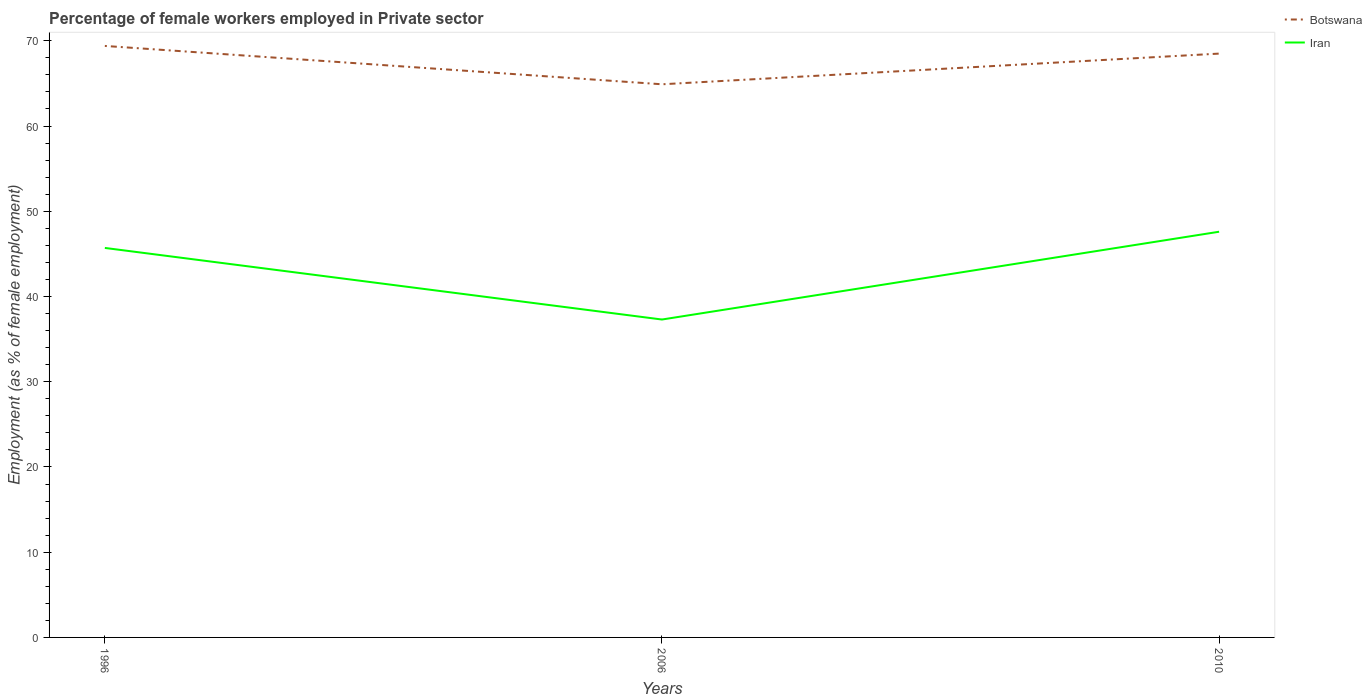Across all years, what is the maximum percentage of females employed in Private sector in Iran?
Your answer should be very brief. 37.3. What is the total percentage of females employed in Private sector in Iran in the graph?
Ensure brevity in your answer.  -10.3. What is the difference between the highest and the second highest percentage of females employed in Private sector in Iran?
Your answer should be compact. 10.3. What is the difference between the highest and the lowest percentage of females employed in Private sector in Iran?
Provide a short and direct response. 2. Is the percentage of females employed in Private sector in Iran strictly greater than the percentage of females employed in Private sector in Botswana over the years?
Your answer should be compact. Yes. How many years are there in the graph?
Your answer should be compact. 3. Are the values on the major ticks of Y-axis written in scientific E-notation?
Your response must be concise. No. Does the graph contain any zero values?
Your answer should be very brief. No. Does the graph contain grids?
Ensure brevity in your answer.  No. Where does the legend appear in the graph?
Your response must be concise. Top right. How many legend labels are there?
Offer a terse response. 2. What is the title of the graph?
Keep it short and to the point. Percentage of female workers employed in Private sector. What is the label or title of the X-axis?
Keep it short and to the point. Years. What is the label or title of the Y-axis?
Provide a succinct answer. Employment (as % of female employment). What is the Employment (as % of female employment) in Botswana in 1996?
Ensure brevity in your answer.  69.4. What is the Employment (as % of female employment) in Iran in 1996?
Offer a very short reply. 45.7. What is the Employment (as % of female employment) in Botswana in 2006?
Provide a short and direct response. 64.9. What is the Employment (as % of female employment) in Iran in 2006?
Provide a short and direct response. 37.3. What is the Employment (as % of female employment) of Botswana in 2010?
Offer a terse response. 68.5. What is the Employment (as % of female employment) of Iran in 2010?
Your response must be concise. 47.6. Across all years, what is the maximum Employment (as % of female employment) of Botswana?
Your answer should be compact. 69.4. Across all years, what is the maximum Employment (as % of female employment) in Iran?
Offer a very short reply. 47.6. Across all years, what is the minimum Employment (as % of female employment) of Botswana?
Provide a short and direct response. 64.9. Across all years, what is the minimum Employment (as % of female employment) in Iran?
Offer a very short reply. 37.3. What is the total Employment (as % of female employment) in Botswana in the graph?
Give a very brief answer. 202.8. What is the total Employment (as % of female employment) in Iran in the graph?
Keep it short and to the point. 130.6. What is the difference between the Employment (as % of female employment) in Botswana in 1996 and that in 2006?
Provide a succinct answer. 4.5. What is the difference between the Employment (as % of female employment) in Iran in 1996 and that in 2006?
Keep it short and to the point. 8.4. What is the difference between the Employment (as % of female employment) in Iran in 1996 and that in 2010?
Your answer should be very brief. -1.9. What is the difference between the Employment (as % of female employment) of Iran in 2006 and that in 2010?
Your answer should be very brief. -10.3. What is the difference between the Employment (as % of female employment) of Botswana in 1996 and the Employment (as % of female employment) of Iran in 2006?
Provide a succinct answer. 32.1. What is the difference between the Employment (as % of female employment) of Botswana in 1996 and the Employment (as % of female employment) of Iran in 2010?
Ensure brevity in your answer.  21.8. What is the average Employment (as % of female employment) of Botswana per year?
Your response must be concise. 67.6. What is the average Employment (as % of female employment) in Iran per year?
Your answer should be very brief. 43.53. In the year 1996, what is the difference between the Employment (as % of female employment) in Botswana and Employment (as % of female employment) in Iran?
Provide a succinct answer. 23.7. In the year 2006, what is the difference between the Employment (as % of female employment) in Botswana and Employment (as % of female employment) in Iran?
Offer a terse response. 27.6. In the year 2010, what is the difference between the Employment (as % of female employment) in Botswana and Employment (as % of female employment) in Iran?
Keep it short and to the point. 20.9. What is the ratio of the Employment (as % of female employment) in Botswana in 1996 to that in 2006?
Make the answer very short. 1.07. What is the ratio of the Employment (as % of female employment) in Iran in 1996 to that in 2006?
Offer a very short reply. 1.23. What is the ratio of the Employment (as % of female employment) of Botswana in 1996 to that in 2010?
Give a very brief answer. 1.01. What is the ratio of the Employment (as % of female employment) of Iran in 1996 to that in 2010?
Ensure brevity in your answer.  0.96. What is the ratio of the Employment (as % of female employment) in Iran in 2006 to that in 2010?
Make the answer very short. 0.78. What is the difference between the highest and the second highest Employment (as % of female employment) in Botswana?
Offer a very short reply. 0.9. What is the difference between the highest and the second highest Employment (as % of female employment) of Iran?
Give a very brief answer. 1.9. What is the difference between the highest and the lowest Employment (as % of female employment) in Botswana?
Your answer should be compact. 4.5. What is the difference between the highest and the lowest Employment (as % of female employment) in Iran?
Ensure brevity in your answer.  10.3. 